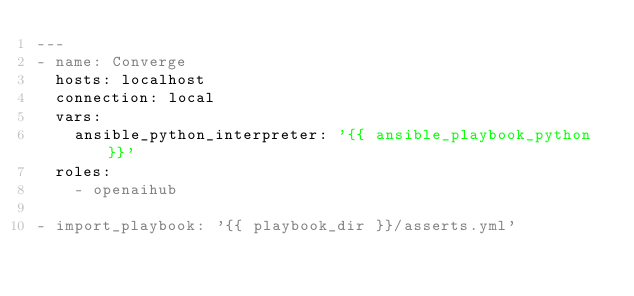Convert code to text. <code><loc_0><loc_0><loc_500><loc_500><_YAML_>---
- name: Converge
  hosts: localhost
  connection: local
  vars:
    ansible_python_interpreter: '{{ ansible_playbook_python }}'
  roles:
    - openaihub

- import_playbook: '{{ playbook_dir }}/asserts.yml'
</code> 